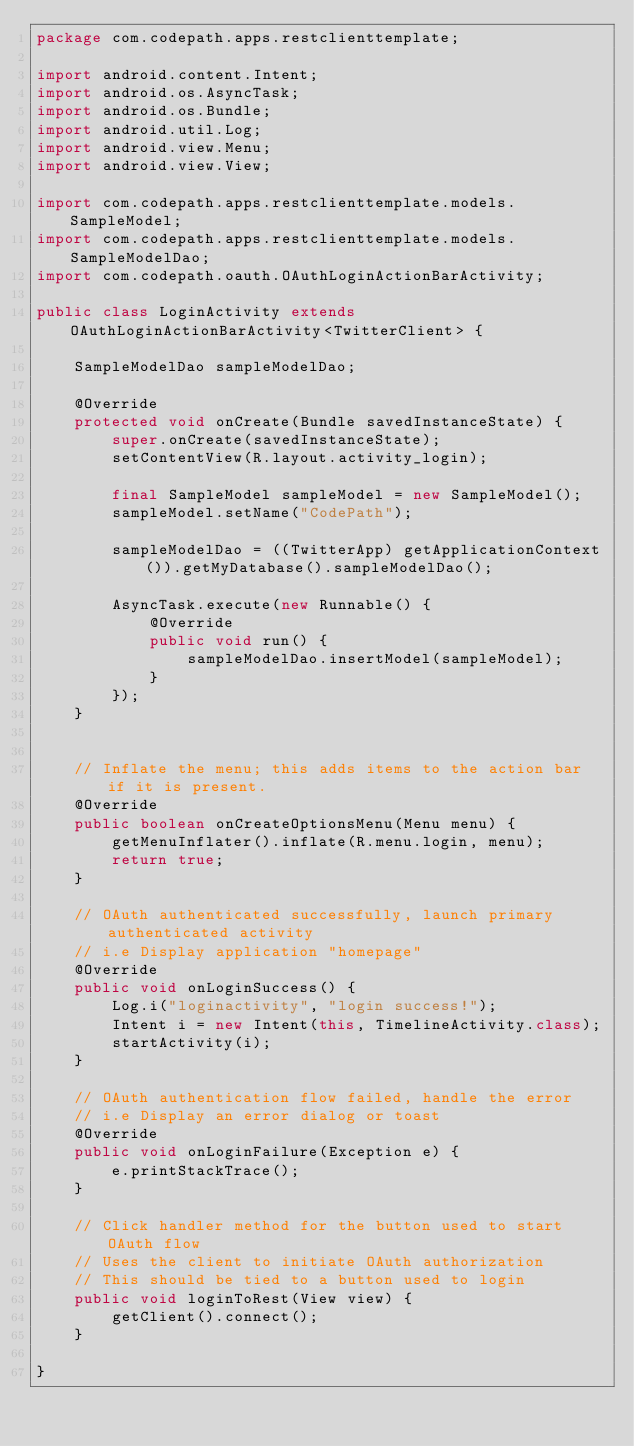Convert code to text. <code><loc_0><loc_0><loc_500><loc_500><_Java_>package com.codepath.apps.restclienttemplate;

import android.content.Intent;
import android.os.AsyncTask;
import android.os.Bundle;
import android.util.Log;
import android.view.Menu;
import android.view.View;

import com.codepath.apps.restclienttemplate.models.SampleModel;
import com.codepath.apps.restclienttemplate.models.SampleModelDao;
import com.codepath.oauth.OAuthLoginActionBarActivity;

public class LoginActivity extends OAuthLoginActionBarActivity<TwitterClient> {

	SampleModelDao sampleModelDao;
	
	@Override
	protected void onCreate(Bundle savedInstanceState) {
		super.onCreate(savedInstanceState);
		setContentView(R.layout.activity_login);

		final SampleModel sampleModel = new SampleModel();
		sampleModel.setName("CodePath");

		sampleModelDao = ((TwitterApp) getApplicationContext()).getMyDatabase().sampleModelDao();

		AsyncTask.execute(new Runnable() {
			@Override
			public void run() {
				sampleModelDao.insertModel(sampleModel);
			}
		});
	}


	// Inflate the menu; this adds items to the action bar if it is present.
	@Override
	public boolean onCreateOptionsMenu(Menu menu) {
		getMenuInflater().inflate(R.menu.login, menu);
		return true;
	}

	// OAuth authenticated successfully, launch primary authenticated activity
	// i.e Display application "homepage"
	@Override
	public void onLoginSuccess() {
		Log.i("loginactivity", "login success!");
		Intent i = new Intent(this, TimelineActivity.class);
		startActivity(i);
	}

	// OAuth authentication flow failed, handle the error
	// i.e Display an error dialog or toast
	@Override
	public void onLoginFailure(Exception e) {
		e.printStackTrace();
	}

	// Click handler method for the button used to start OAuth flow
	// Uses the client to initiate OAuth authorization
	// This should be tied to a button used to login
	public void loginToRest(View view) {
		getClient().connect();
	}

}
</code> 